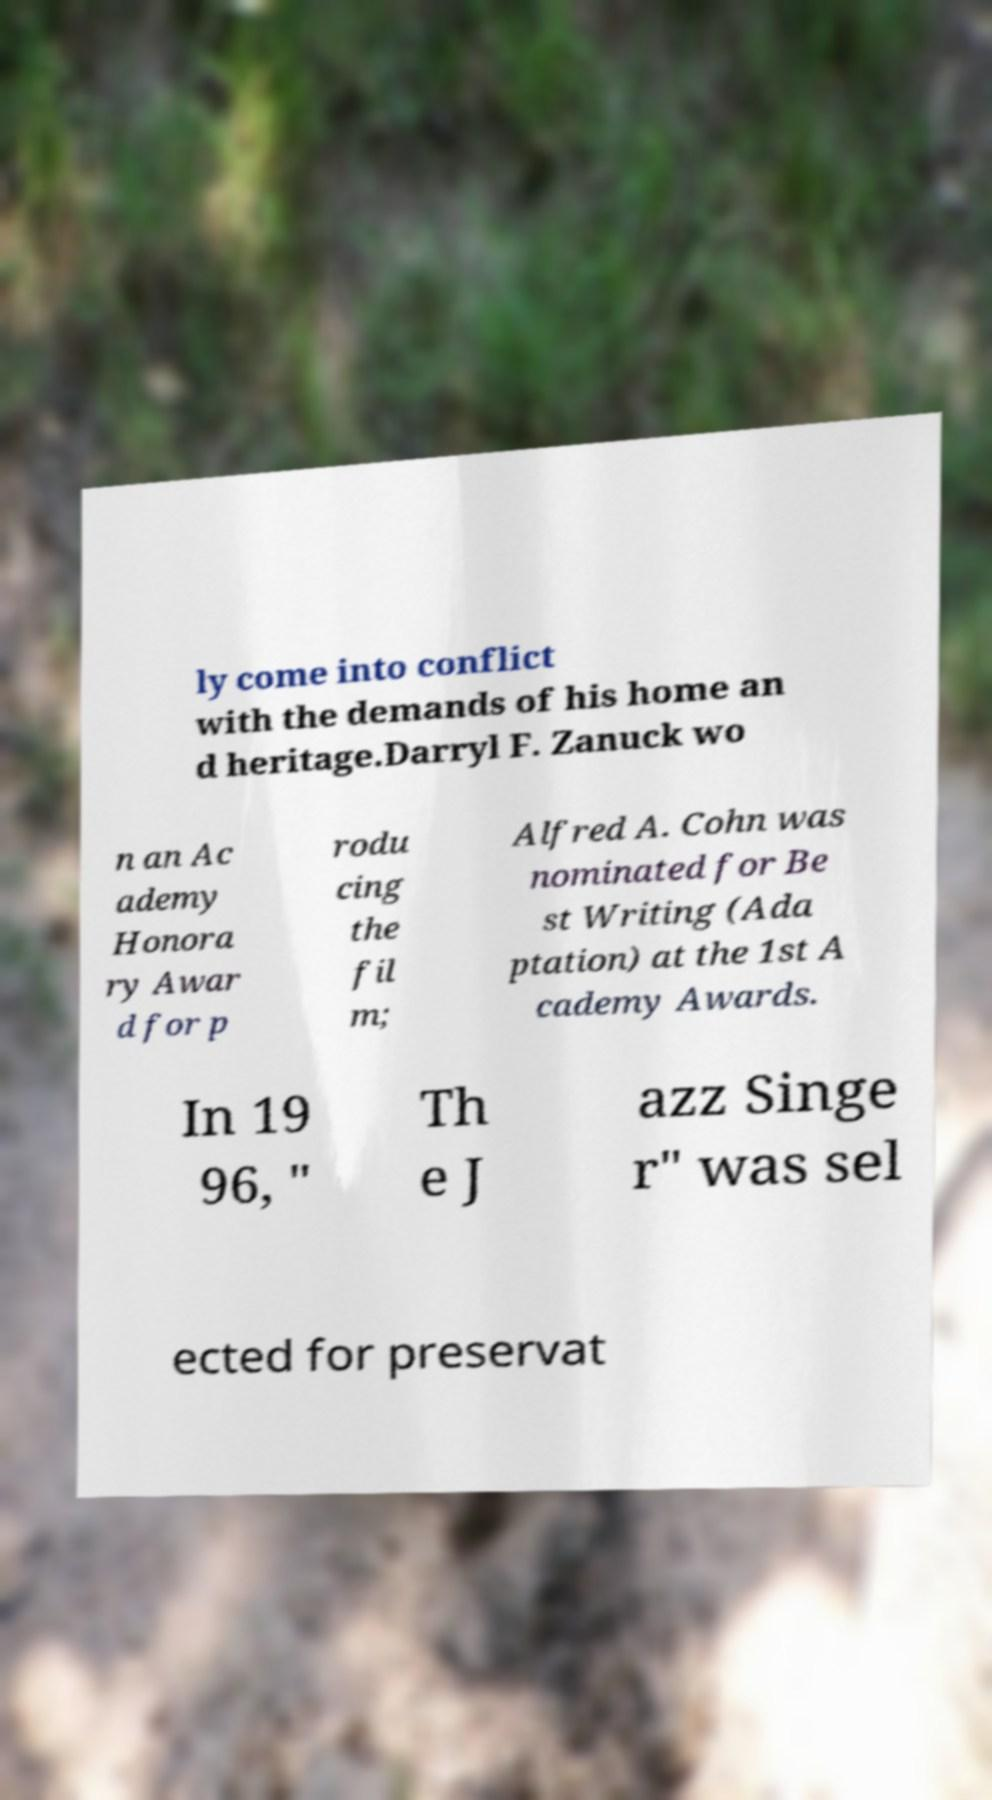There's text embedded in this image that I need extracted. Can you transcribe it verbatim? ly come into conflict with the demands of his home an d heritage.Darryl F. Zanuck wo n an Ac ademy Honora ry Awar d for p rodu cing the fil m; Alfred A. Cohn was nominated for Be st Writing (Ada ptation) at the 1st A cademy Awards. In 19 96, " Th e J azz Singe r" was sel ected for preservat 